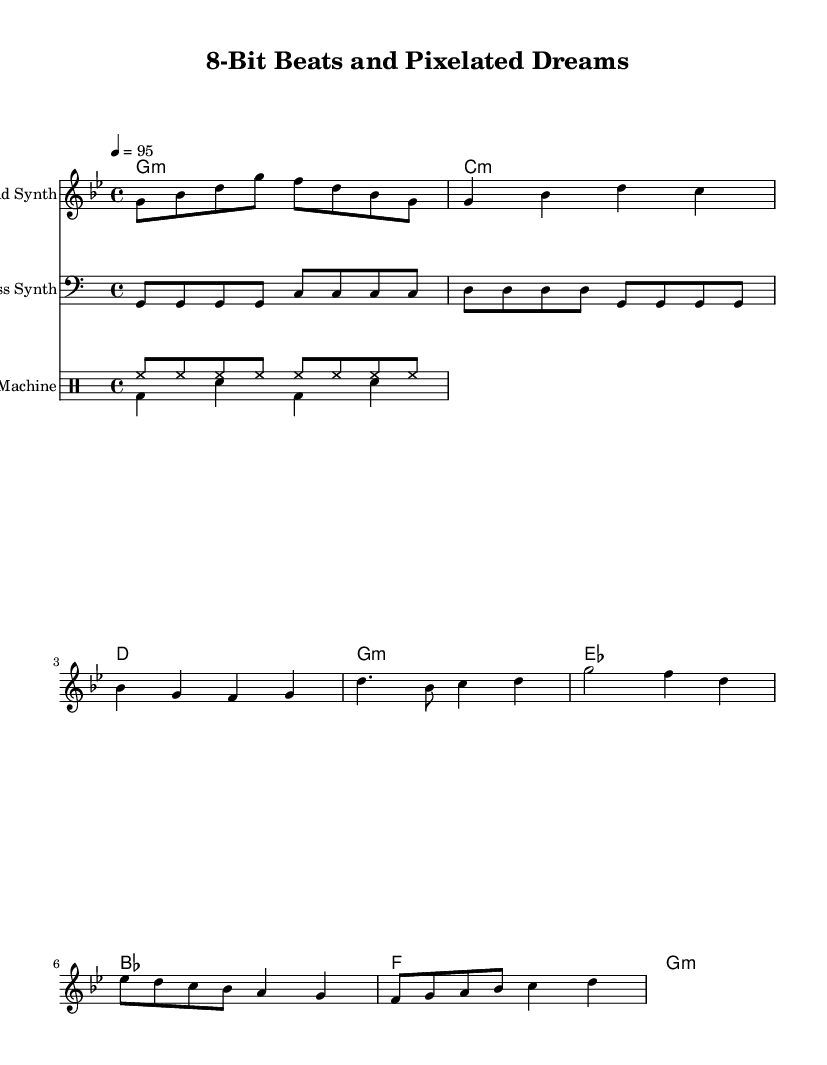What is the key signature of this music? The key signature is G minor, which has two flats (B♭ and E♭). This can be identified at the beginning of the staff where the flats are indicated.
Answer: G minor What is the time signature used in this piece? The time signature is 4/4, which is shown at the beginning of the score. This means there are four beats in each measure and a quarter note gets one beat.
Answer: 4/4 What is the tempo marking for this piece? The tempo marking is quarter note equals 95, indicated by the tempo instruction at the beginning of the score. This signifies the speed of the music, meaning a quarter note should be played at a rate of 95 beats per minute.
Answer: 95 How many measures are in the chorus section? The chorus section consists of 2 measures, as seen in the segments after the 'Chorus' label in the melody part. Each segment is counted as a measure, leading to a total of 2.
Answer: 2 What type of instrument is indicated for the lead synth? The lead synth is indicated on the staff as the instrument name for the melody line. This shows the intended sound and texture for that part of the piece.
Answer: Lead Synth What rhythmic pattern do the drums follow during the verse? The drum pattern for the verse includes a hi-hat and bass drum pattern, specifically with high-hat eighth notes and a bass drum on the first and third beats. This showcases the typical rhythmic structure used in hip hop music.
Answer: Hi-hat and bass drum 